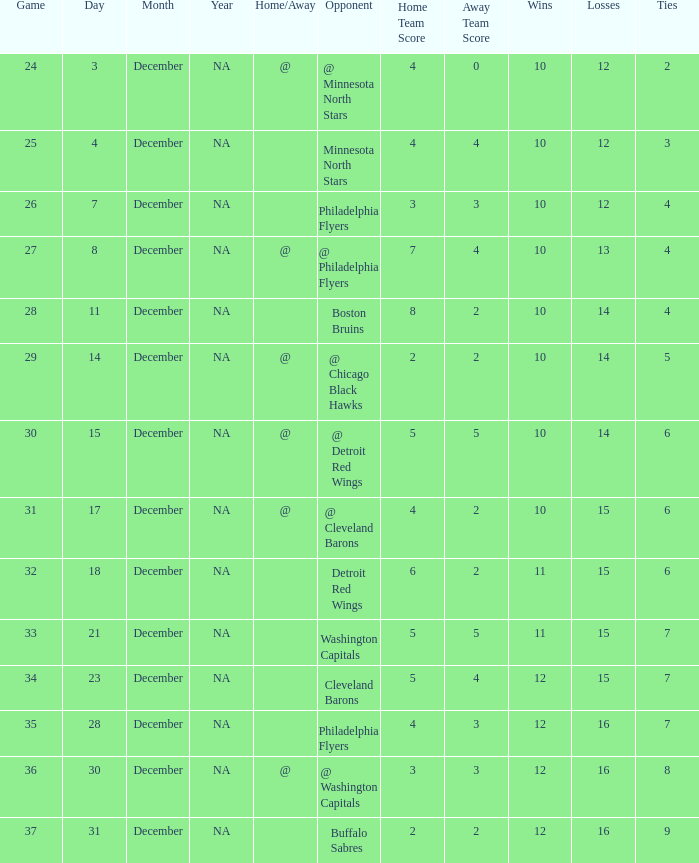What is the lowest December, when Score is "4 - 4"? 4.0. 